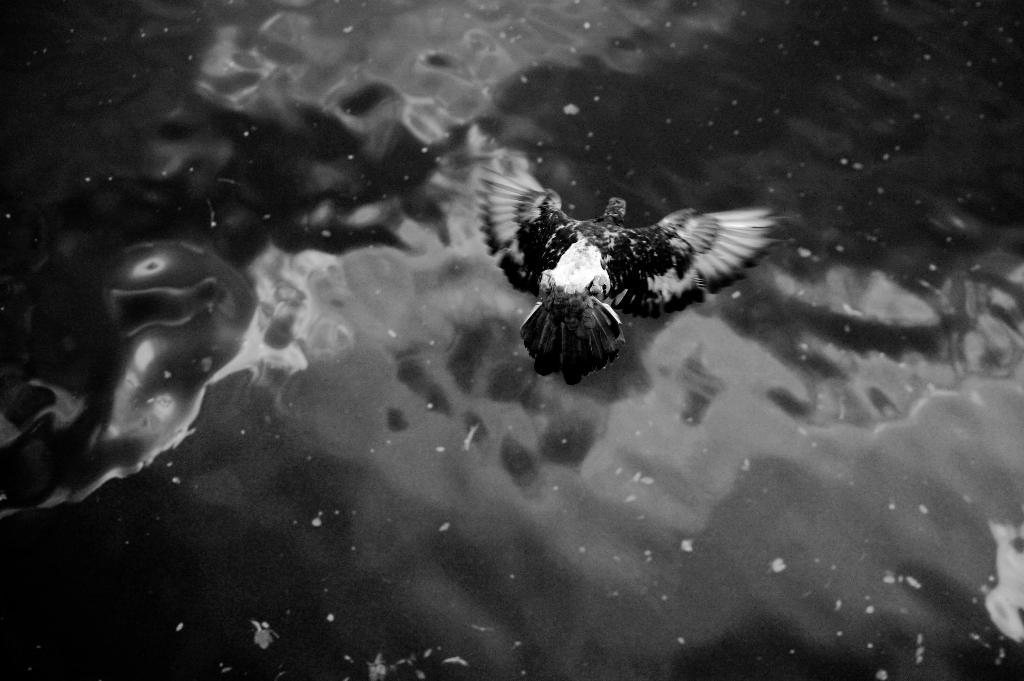What is the color scheme of the image? The image is black and white. What can be seen flying in the air in the image? There is a bird flying in the air in the image. What natural element is visible in the image? There is water visible in the image. What type of laborer can be seen working near the water in the image? There is no laborer present in the image; it only features a bird flying in the air and water. What magical effect is visible in the image? There is no magical effect present in the image; it is a simple depiction of a bird flying over water. 